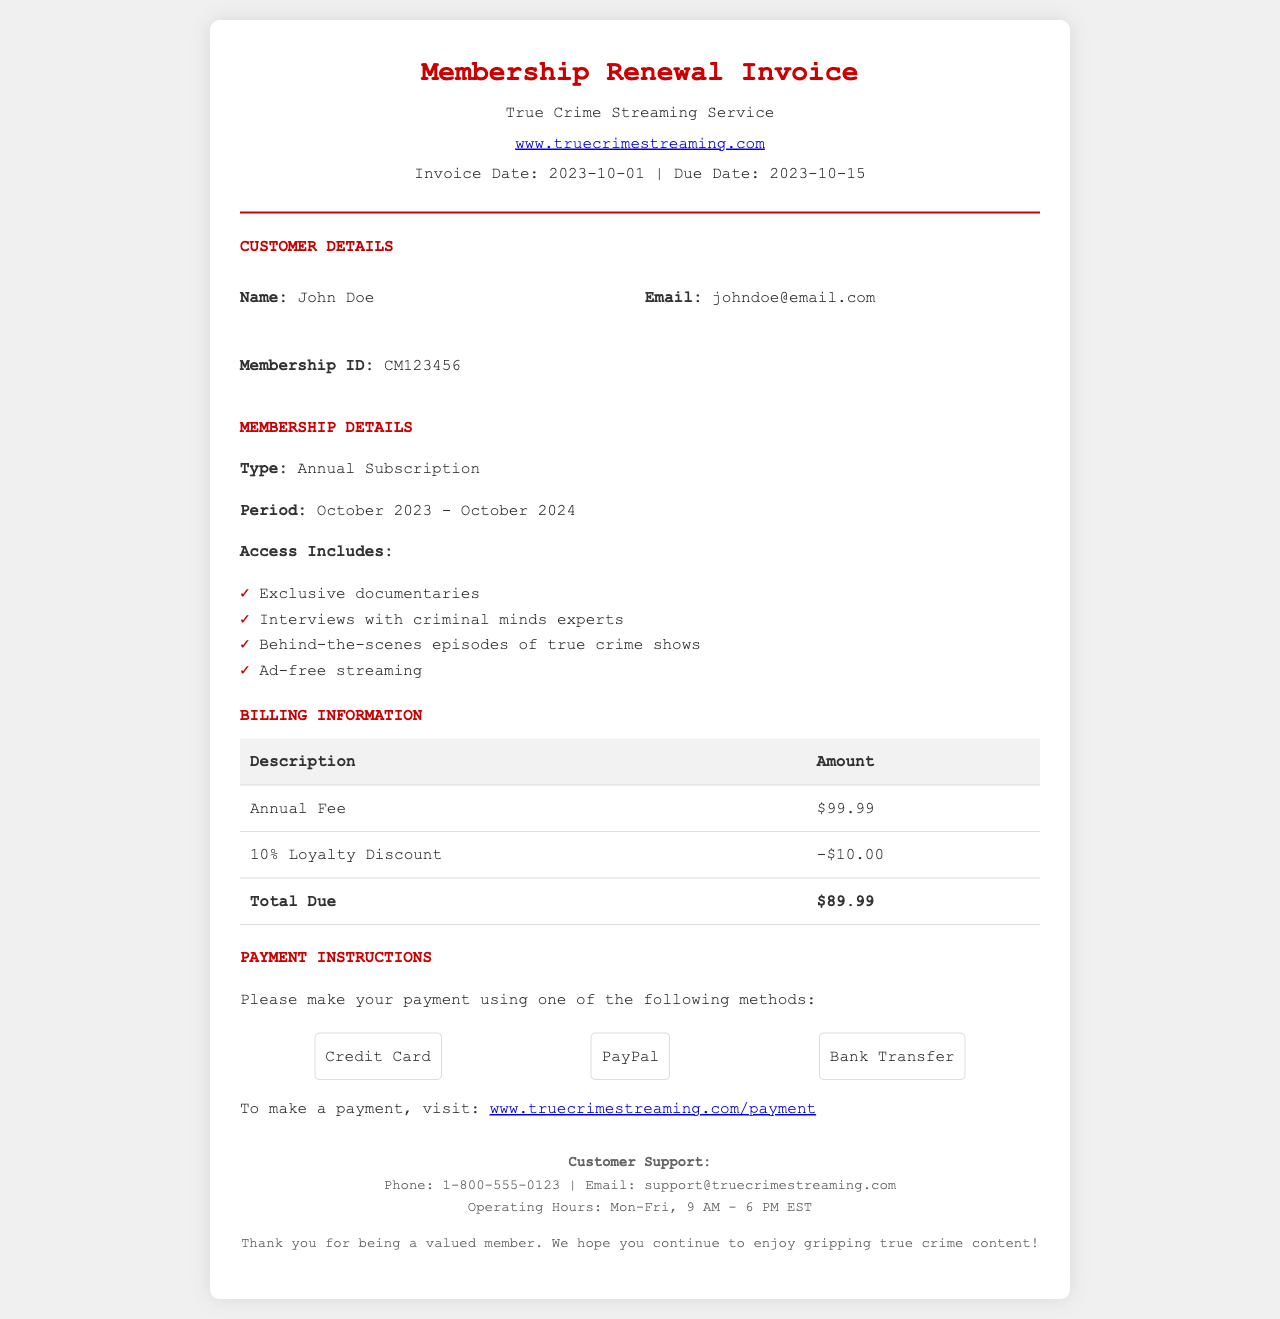what is the invoice date? The invoice date is provided in the document header, indicating when the invoice was created.
Answer: 2023-10-01 what is the total amount due? The total amount due is calculated by subtracting the loyalty discount from the annual fee, as shown in the billing table.
Answer: $89.99 who is the customer? The customer's name is given in the customer details section, identifying the individual responsible for the invoice.
Answer: John Doe what type of subscription is mentioned? The membership details specify the subscription type, indicating what type of service the customer has subscribed to.
Answer: Annual Subscription what is the loyalty discount percentage? The loyalty discount is explicitly noted in the billing table, showing the percentage off the annual fee for returning members.
Answer: 10% how long is the membership period? The membership period outlines the duration of the subscription, indicating when it starts and ends.
Answer: October 2023 - October 2024 what are the payment methods available? The payment instructions section lists the options customers can choose from for making their payment.
Answer: Credit Card, PayPal, Bank Transfer what is the membership ID? The membership ID is a unique identifier given to the customer in the details section of the invoice.
Answer: CM123456 what are the operating hours for customer support? The footer mentions the hours during which customer support is available for inquiries.
Answer: Mon-Fri, 9 AM - 6 PM EST 